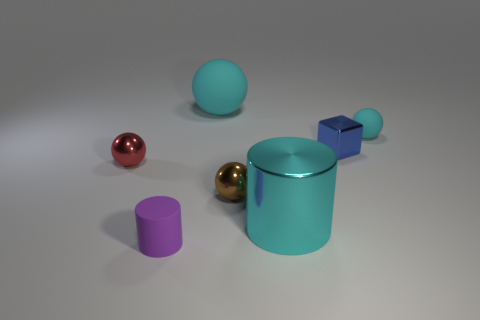There is another cyan thing that is the same shape as the big matte thing; what is it made of?
Provide a short and direct response. Rubber. There is a small cyan rubber object; what shape is it?
Ensure brevity in your answer.  Sphere. There is a object that is behind the small red metal object and left of the large cyan metallic cylinder; what material is it?
Your response must be concise. Rubber. What is the shape of the small brown object that is made of the same material as the small red sphere?
Your answer should be very brief. Sphere. What is the size of the cube that is the same material as the brown thing?
Your answer should be compact. Small. What shape is the metal thing that is to the left of the large metallic object and in front of the red sphere?
Give a very brief answer. Sphere. There is a rubber object that is in front of the shiny ball behind the small brown sphere; how big is it?
Offer a terse response. Small. What number of other things are there of the same color as the cube?
Offer a terse response. 0. What is the material of the small blue object?
Your answer should be compact. Metal. Is there a metal cylinder?
Offer a very short reply. Yes. 